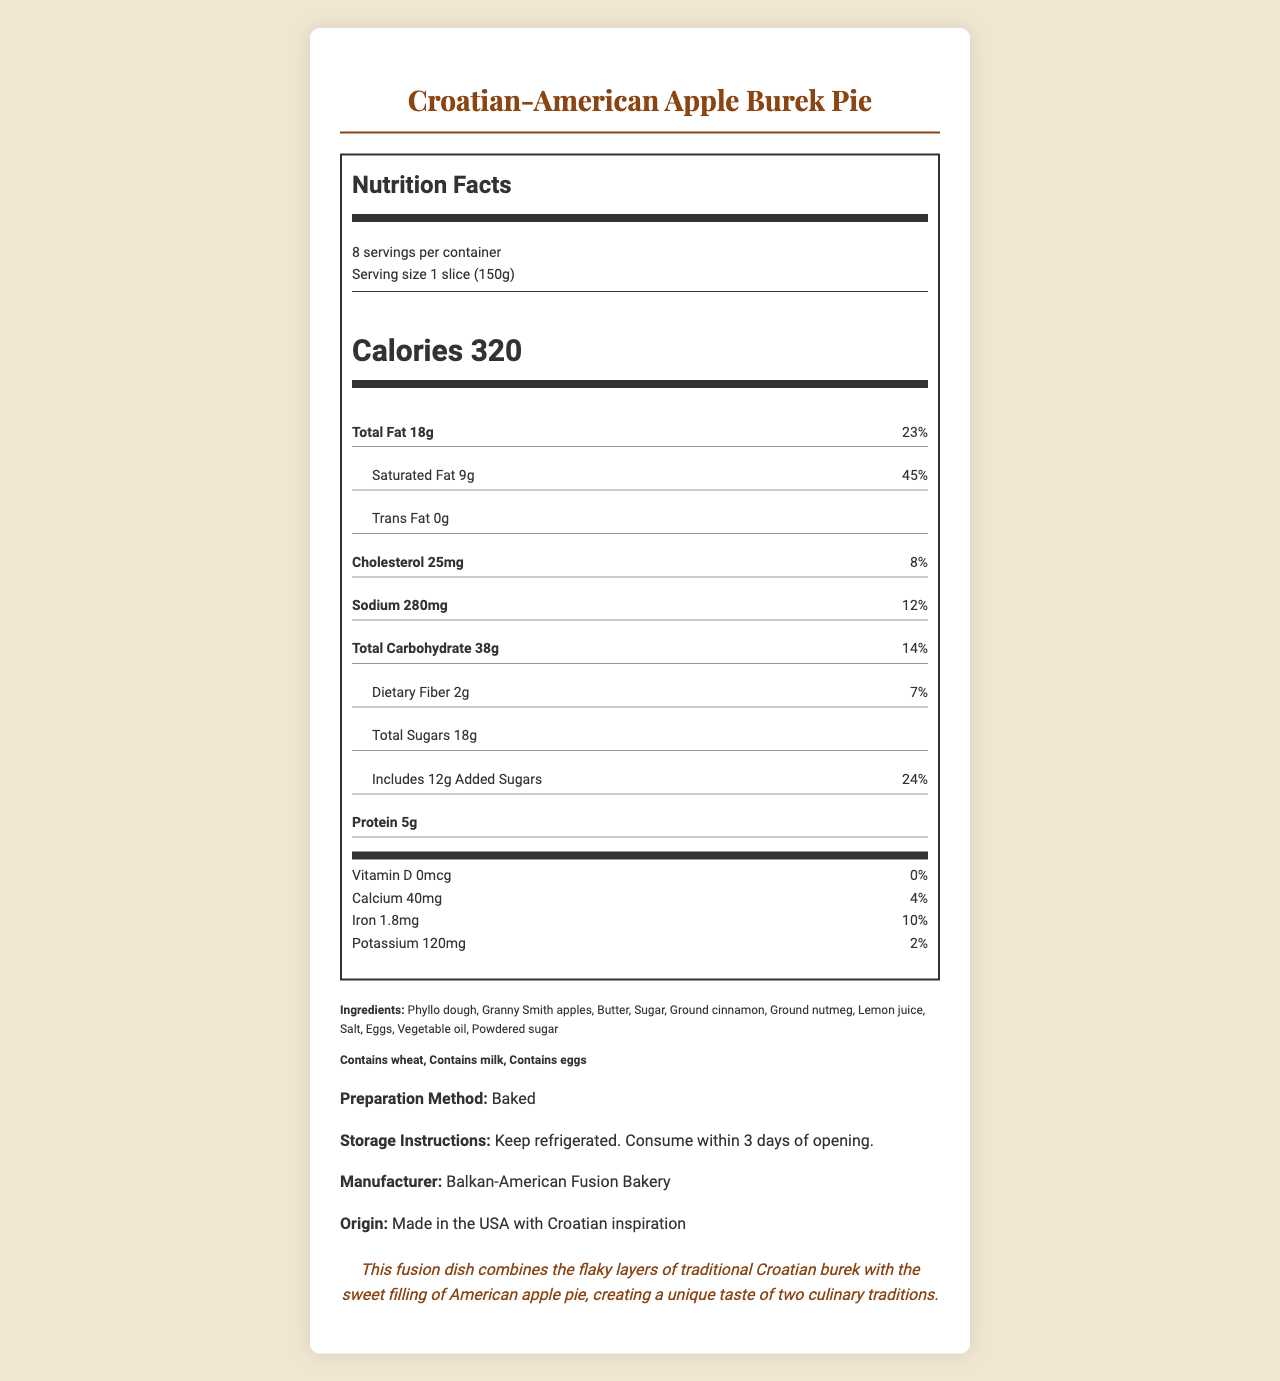what is the serving size of the Croatian-American Apple Burek Pie? The serving size is clearly listed as "1 slice (150g)" in the document.
Answer: 1 slice (150g) how many servings are in the entire container? The document specifies that there are 8 servings per container.
Answer: 8 servings how many grams of total fat are in one serving? The total fat content per serving is listed as 18g.
Answer: 18g what is the daily value percentage for saturated fat? The daily value percentage for saturated fat is given as 45%.
Answer: 45% what is the preparation method for the dish? The preparation method is stated as "Baked".
Answer: Baked which of the following ingredients is NOT listed? A. Lemon juice B. Ground cinnamon C. Honey D. Vegetable oil The ingredients list includes lemon juice, ground cinnamon, and vegetable oil, but not honey.
Answer: C. Honey how much cholesterol is in one serving? A. 25mg B. 50mg C. 75mg The cholesterol content in one serving is listed as 25mg.
Answer: A. 25mg what allergens are present in the dish? The allergens listed in the document are wheat, milk, and eggs.
Answer: Contains wheat, Contains milk, Contains eggs is this product suitable for a gluten-free diet? The product contains wheat, which is not suitable for a gluten-free diet.
Answer: No describe the main idea of the document. The document outlines the various aspects of the Croatian-American Apple Burek Pie, including its nutritional facts, ingredients, allergens, preparation, and cultural significance, giving a comprehensive view of what the product contains and how it should be handled.
Answer: The document provides nutritional and ingredient information about the Croatian-American Apple Burek Pie, a fusion dish that combines elements of Croatian burek and American apple pie. It includes details on serving size, nutritional content, ingredients, allergens, preparation method, storage instructions, and cultural significance. how much added sugar is there per serving? The document states that there are 12g of added sugars per serving.
Answer: 12g what is the recommended storage condition? The storage instructions are to keep the product refrigerated and consume it within 3 days of opening.
Answer: Keep refrigerated. Consume within 3 days of opening. what is the amount of iron in one serving? The document lists the amount of iron per serving as 1.8mg.
Answer: 1.8mg how many grams of protein are in one slice? One slice contains 5g of protein.
Answer: 5g who is the manufacturer of this dish? The manufacturer is listed as "Balkan-American Fusion Bakery".
Answer: Balkan-American Fusion Bakery does the dish contain trans fat? The document states that the trans fat content is 0g.
Answer: No what is the cultural significance of this dish? The document mentions that the dish is inspired by both Croatian burek and American apple pie, blending the two culinary traditions.
Answer: This fusion dish combines the flaky layers of traditional Croatian burek with the sweet filling of American apple pie, creating a unique taste of two culinary traditions. how is the dish marketed in terms of origin? The origin is listed as "Made in the USA with Croatian inspiration."
Answer: Made in the USA with Croatian inspiration how many calories are there in the whole container? Since there are 8 servings per container and each serving has 320 calories, the total is 320 x 8 = 2,560 calories.
Answer: 2,560 calories what type of apples is used in this dish? The ingredient list specifies that Granny Smith apples are used.
Answer: Granny Smith apples which nutrient has a daily value percentage of 24%? The document specifies that the added sugars have a daily value percentage of 24%.
Answer: Added Sugars what are the storage instructions for the product? A. Store at room temperature B. Keep frozen C. Keep refrigerated The storage instructions are given as "Keep refrigerated."
Answer: C. Keep refrigerated 